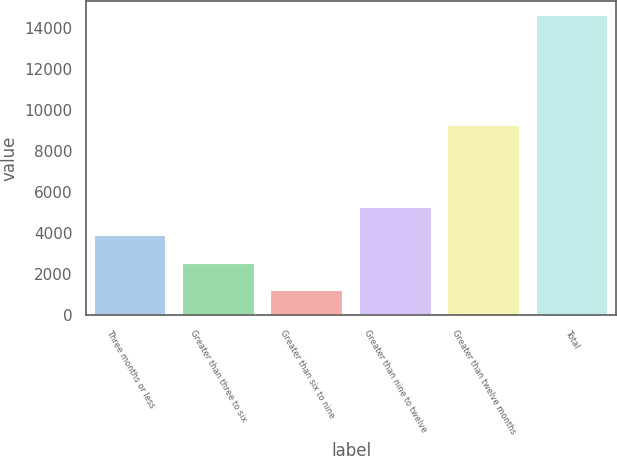Convert chart. <chart><loc_0><loc_0><loc_500><loc_500><bar_chart><fcel>Three months or less<fcel>Greater than three to six<fcel>Greater than six to nine<fcel>Greater than nine to twelve<fcel>Greater than twelve months<fcel>Total<nl><fcel>3865.8<fcel>2522.9<fcel>1180<fcel>5208.7<fcel>9208<fcel>14609<nl></chart> 